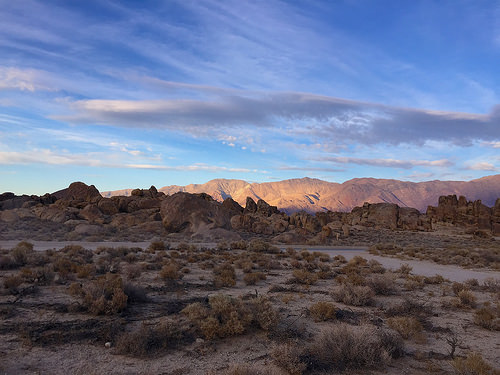<image>
Is the cloud in the sky? Yes. The cloud is contained within or inside the sky, showing a containment relationship. 